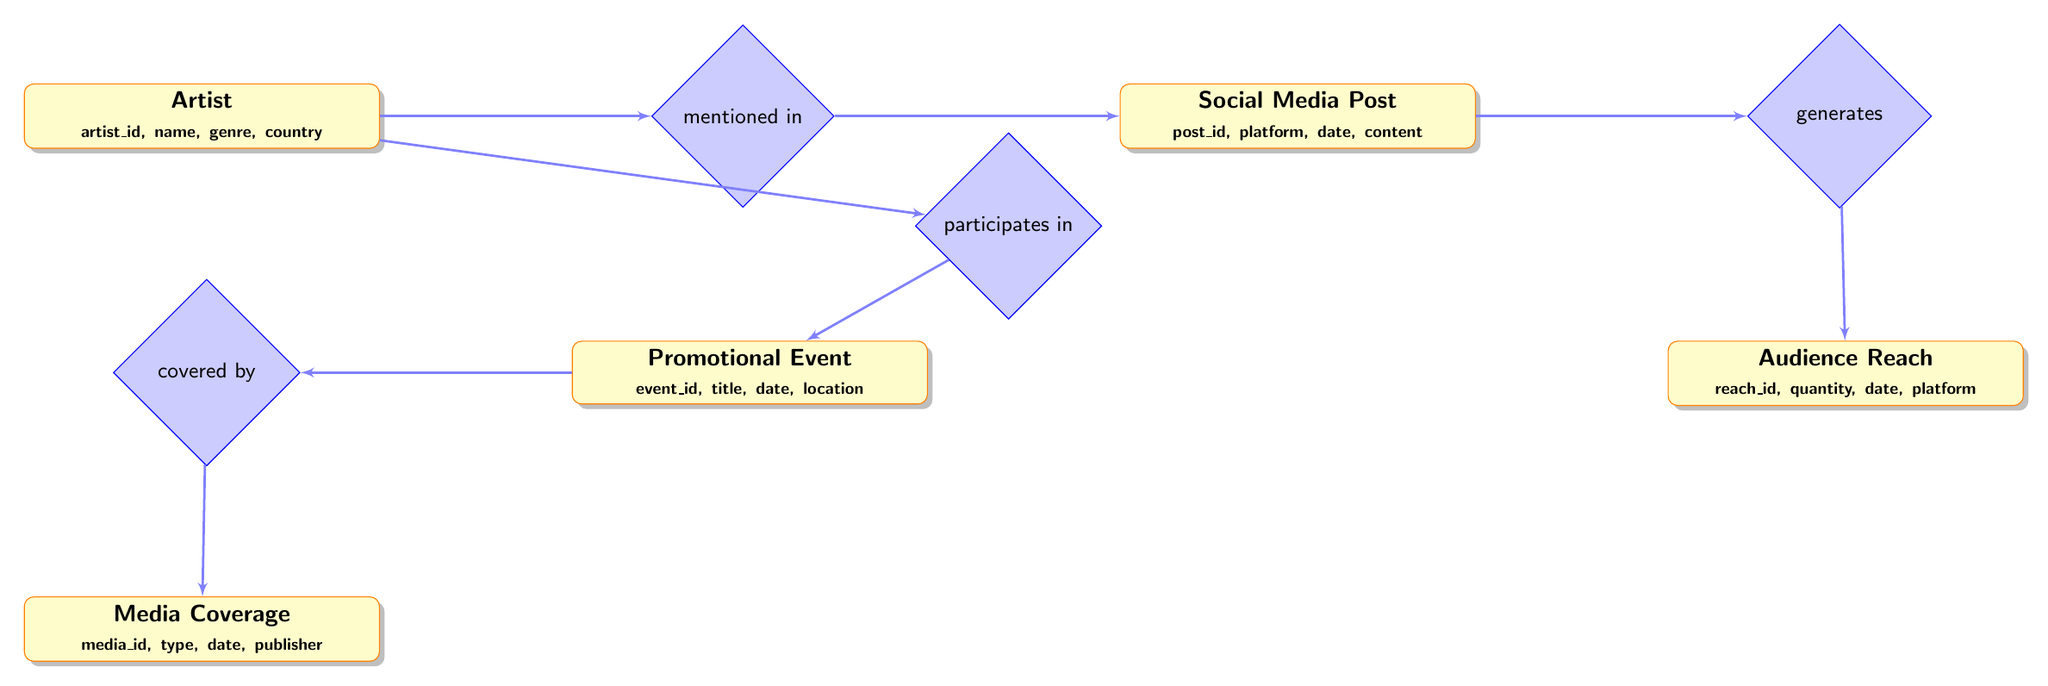What is the total number of entities in this diagram? The diagram contains five entities: Artist, Promotional Event, Media Coverage, Social Media Post, and Audience Reach. Counting these gives a total of five entities.
Answer: 5 What relationship connects Artist and Promotional Event? The relationship between Artist and Promotional Event is labeled "participates in." This indicates that artists take part in promotional events.
Answer: participates in Which entity is covered by Media Coverage? The relationship connecting Promotional Event to Media Coverage is labeled "covered by." This means that the promotional event receives media coverage.
Answer: Promotional Event What relationship links Social Media Post and Audience Reach? The relationship is labeled "generates," indicating that Social Media Posts generate Audience Reach, meaning that posts impact how many people engage with the content.
Answer: generates How many relationships are represented in the diagram? The diagram features four relationships: participates in, covered by, mentioned in, and generates. Counting these provides a total of four relationships.
Answer: 4 Which entity is mentioned in Social Media Post? The relationship "mentioned in" connects Artist to Social Media Post. This means that artists are referenced in social media posts.
Answer: Artist Which entity receives coverage from Media Coverage? Media Coverage covers the Promotional Event. The connection is indicated by the relationship "covered by." This reflects that the promotional event is reported on by various media outlets.
Answer: Promotional Event What attribute is associated with the Artist entity? The Artist entity includes several attributes, one of which is the name. This attribute provides the name of the artist being promoted.
Answer: name What does the Audience Reach entity measure? Audience Reach measures the quantity of engagement or interaction with the content, as indicated by the attribute "quantity." This quantifies how many individuals interacted with the promotional material.
Answer: quantity 